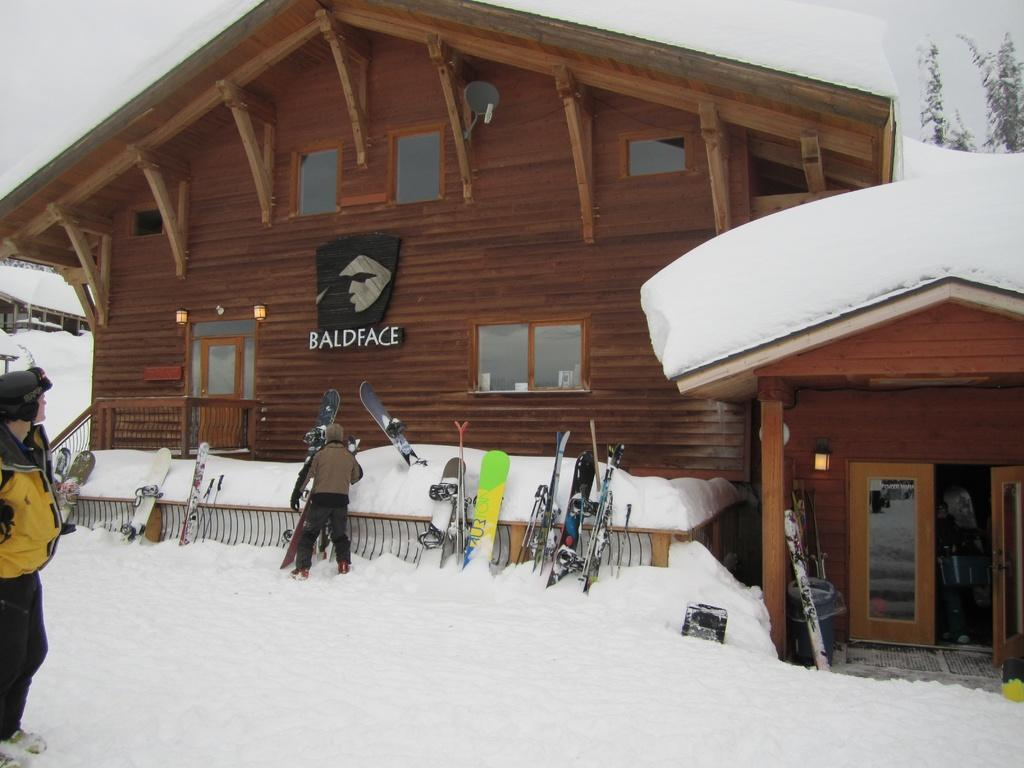What structures are located in the center of the image? There are sheds in the center of the image. What type of weather condition is depicted in the image? There is snow at the bottom of the image. Can you identify any people in the image? Yes, people are visible in the image. What are the ski boards doing in the image? The ski boards are placed on a fence. What can be seen in the background of the image? There is sky visible in the background of the image. What type of trade is being conducted in the image? There is no indication of any trade being conducted in the image. Can you tell me how many trees are present in the image? There is no tree present in the image; it features sheds, snow, people, ski boards, and sky. 